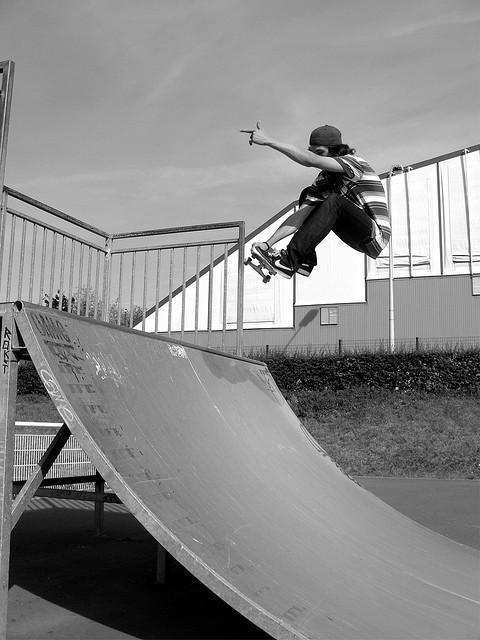How many red cars transporting bicycles to the left are there? there are red cars to the right transporting bicycles too?
Give a very brief answer. 0. 